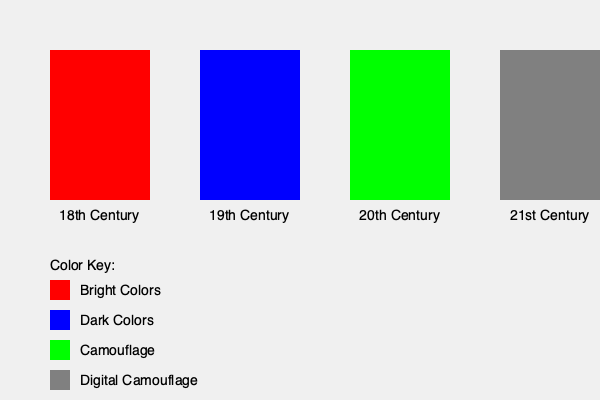Based on the visual representation of military uniform evolution across different time periods, which century marked a significant shift towards more practical and environment-specific designs? To answer this question, let's analyze the evolution of military uniforms across the centuries represented in the graphic:

1. 18th Century: The uniform is depicted in bright red, indicating that visibility and formality were prioritized over practicality in combat situations.

2. 19th Century: The uniform is shown in dark blue, suggesting a shift towards less conspicuous colors, but still not fully adapted for camouflage purposes.

3. 20th Century: There's a dramatic change to green, representing the introduction of camouflage patterns. This marks a significant shift towards more practical designs that blend with natural environments.

4. 21st Century: The uniform is depicted in a gray tone, likely representing digital camouflage patterns, which are an evolution of the 20th-century camouflage concept.

The most significant shift towards practical and environment-specific designs occurred in the 20th century. This is when militaries widely adopted camouflage patterns, moving away from the bright or dark solid colors of previous centuries. The introduction of camouflage reflects a prioritization of soldier concealment and survival in various combat environments.

The 21st-century digital camouflage is an refinement of this concept rather than a completely new shift in design philosophy.
Answer: 20th Century 